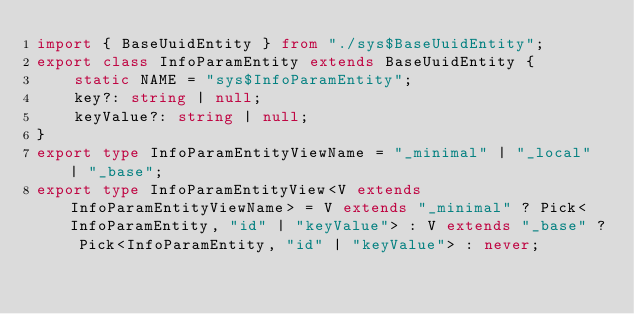<code> <loc_0><loc_0><loc_500><loc_500><_TypeScript_>import { BaseUuidEntity } from "./sys$BaseUuidEntity";
export class InfoParamEntity extends BaseUuidEntity {
    static NAME = "sys$InfoParamEntity";
    key?: string | null;
    keyValue?: string | null;
}
export type InfoParamEntityViewName = "_minimal" | "_local" | "_base";
export type InfoParamEntityView<V extends InfoParamEntityViewName> = V extends "_minimal" ? Pick<InfoParamEntity, "id" | "keyValue"> : V extends "_base" ? Pick<InfoParamEntity, "id" | "keyValue"> : never;
</code> 